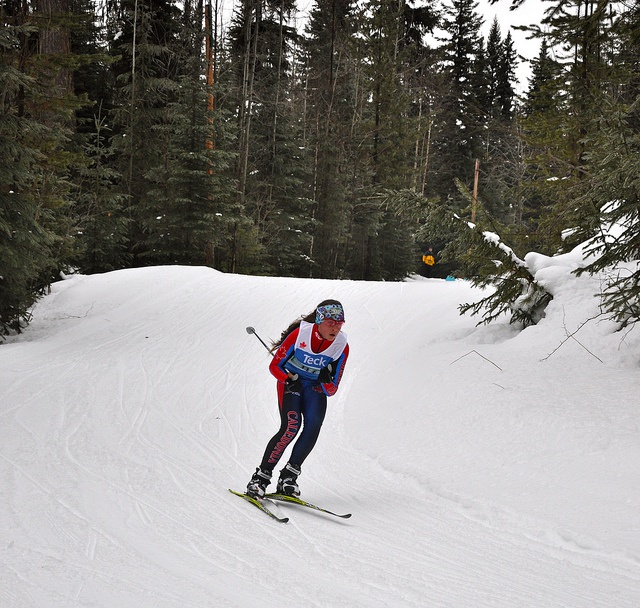Describe the objects in this image and their specific colors. I can see people in lightgray, black, navy, and maroon tones and skis in lightgray, black, gray, and darkgray tones in this image. 